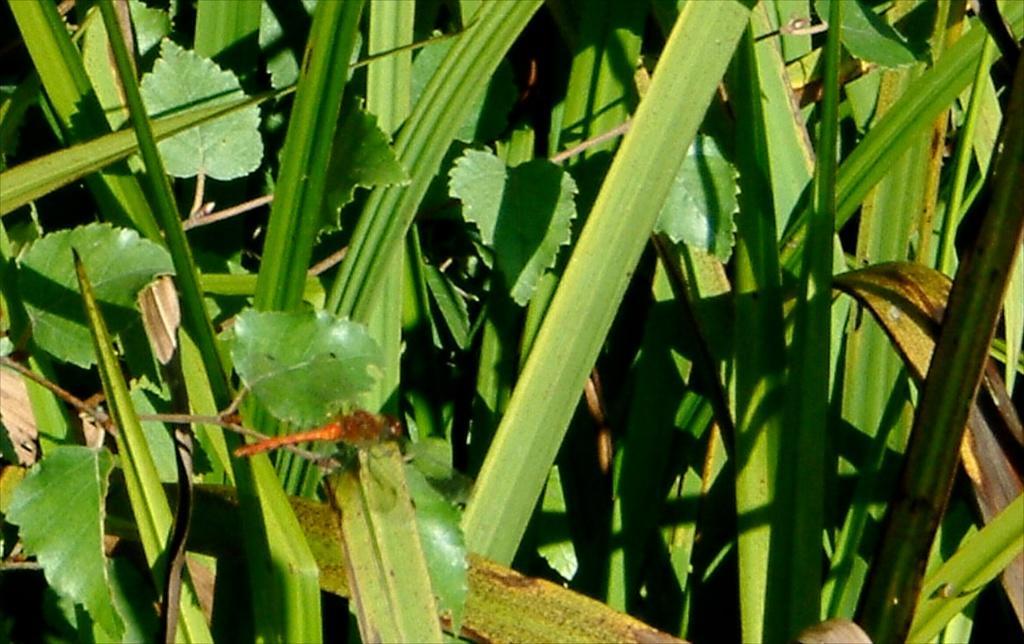How would you summarize this image in a sentence or two? In the foreground of this image, there is a dragonfly on the leaf. In the background, there are plants. 